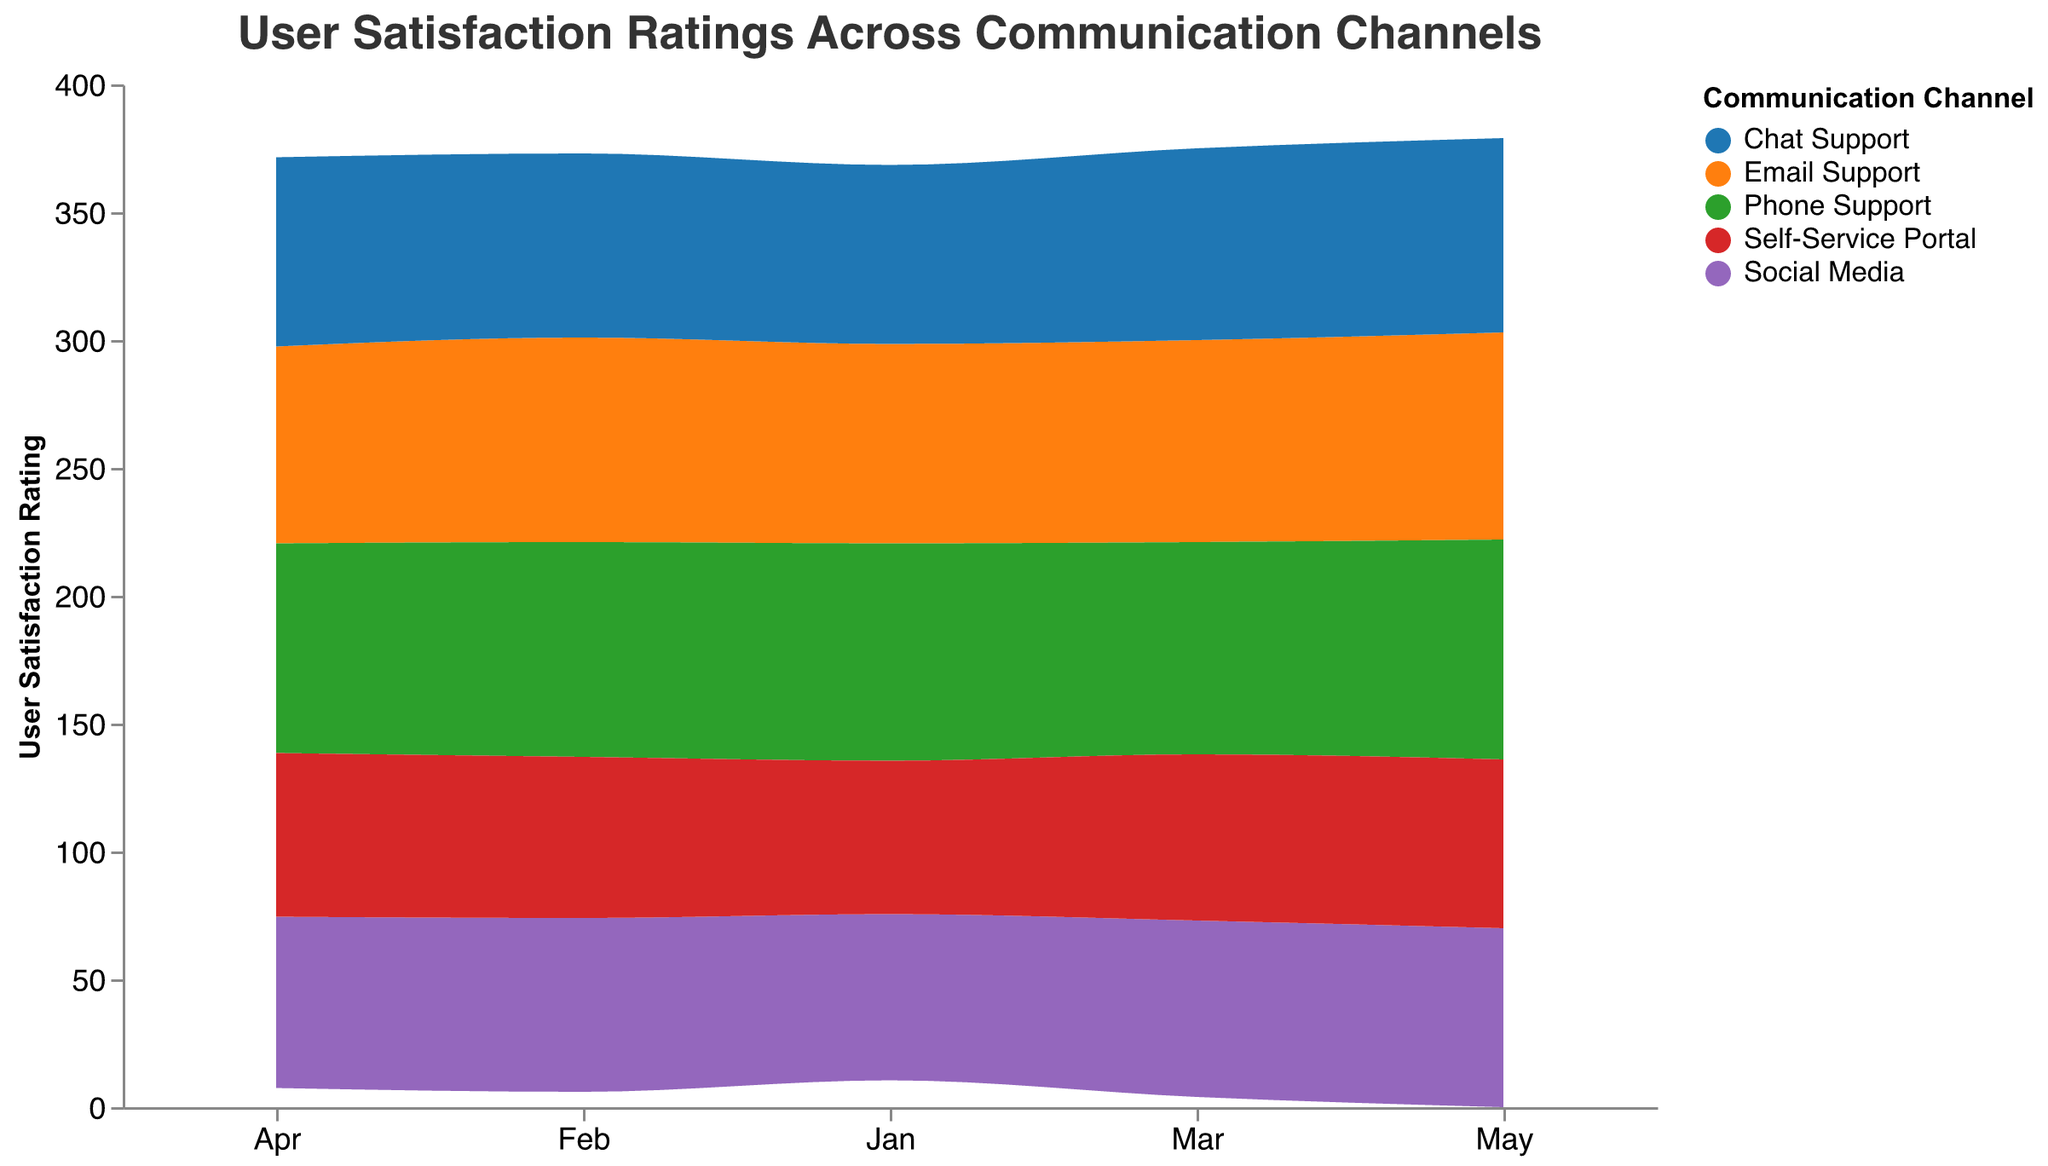What is the title of the figure? The title is displayed prominently at the top center of the figure in a larger font size and reads "User Satisfaction Ratings Across Communication Channels".
Answer: User Satisfaction Ratings Across Communication Channels Which communication channel shows the highest user satisfaction rating in May? To find this, look for the segment labeled "May" on the x-axis and identify which channel has the highest position on the y-axis in that month. The "Phone Support" channel shows the highest rating in May with a satisfaction rating of 86.
Answer: Phone Support How does the total user satisfaction rating for all channels change from January to May? Stack the user satisfaction rating values for each channel from the bottom to the top for the months January and May. Compare the total height of the stacked areas to observe the overall change. The total user satisfaction rating decreases from January to May.
Answer: Decreases Which channel shows the most consistent user satisfaction ratings over the months? To determine consistency, observe the stream graph and identify which channel has a relatively stable area with minimal fluctuations in the y-axis position. "Email Support" shows the most consistent user satisfaction ratings over the months.
Answer: Email Support What's the median user satisfaction rating for "Chat Support" across all months? First, list the ratings for "Chat Support" from January to May: 70, 72, 75, 74, 76. Then, find the median value by arranging the ratings in ascending order and selecting the middle value. The median value is 74.
Answer: 74 How does the user satisfaction rating for "Social Media" change from January to April? Examine the stream segment for "Social Media" from January to April and note the y-axis positions for these months: It moves from 65 to 68 to 69 and then decreases slightly to 67.
Answer: Increases, then decreases Which months show the highest overall user satisfaction ratings? Sum the user satisfaction ratings for all channels for each month and compare these totals. January shows a higher overall rating compared to the other months.
Answer: January Are there any channels where user satisfaction decreases continuously from January to May? Trace each channel's stream from January to May and look for a continuous downward slope. "Phone Support" shows a decrease from Jan (85) to Apr (82) but increases again in May (86). None of the channels show a continuous decrease.
Answer: No What is the average user satisfaction rating for "Self-Service Portal" over the five months? List the ratings for "Self-Service Portal" from January to May: 60, 63, 65, 64, 66. Calculate the average by summing these values (60 + 63 + 65 + 64 + 66 = 318) and dividing by the number of months (318 / 5). The average rating is 63.6.
Answer: 63.6 